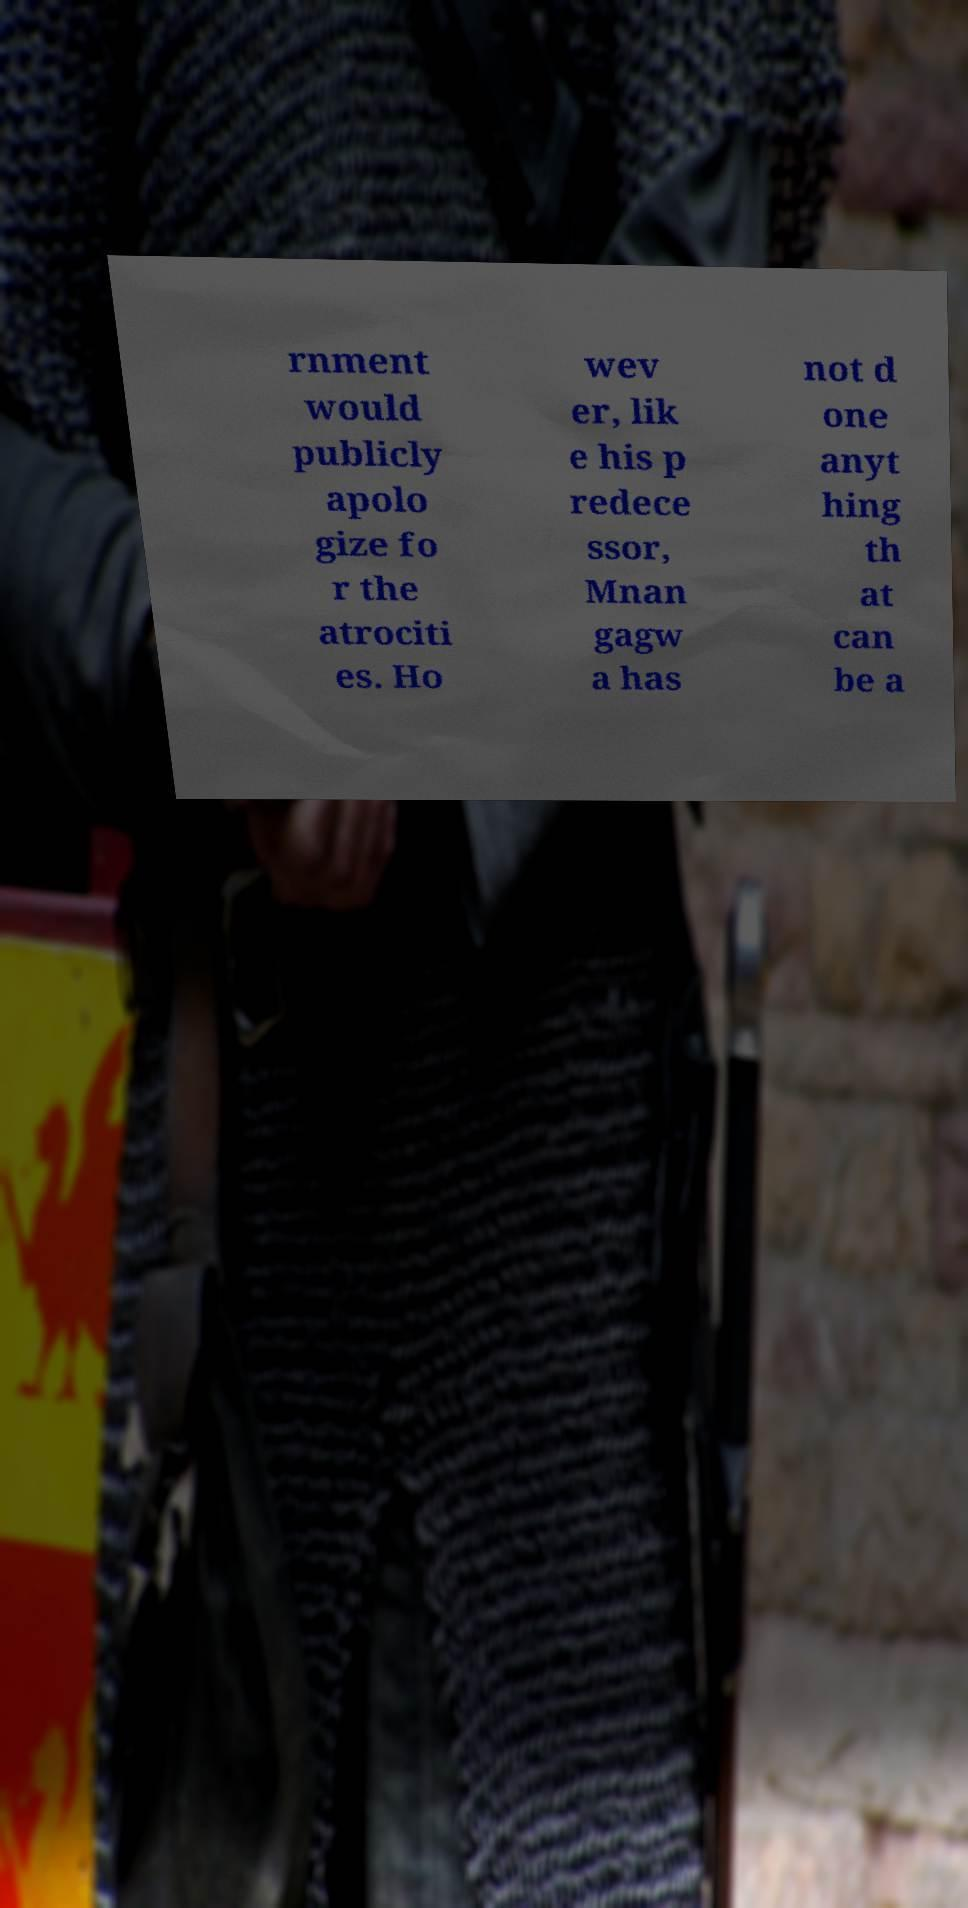Could you extract and type out the text from this image? rnment would publicly apolo gize fo r the atrociti es. Ho wev er, lik e his p redece ssor, Mnan gagw a has not d one anyt hing th at can be a 